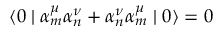Convert formula to latex. <formula><loc_0><loc_0><loc_500><loc_500>\langle 0 | { \alpha } _ { m } ^ { \mu } { \alpha } _ { n } ^ { \nu } + { \alpha } _ { n } ^ { \nu } { \alpha } _ { m } ^ { \mu } | 0 \rangle = 0</formula> 